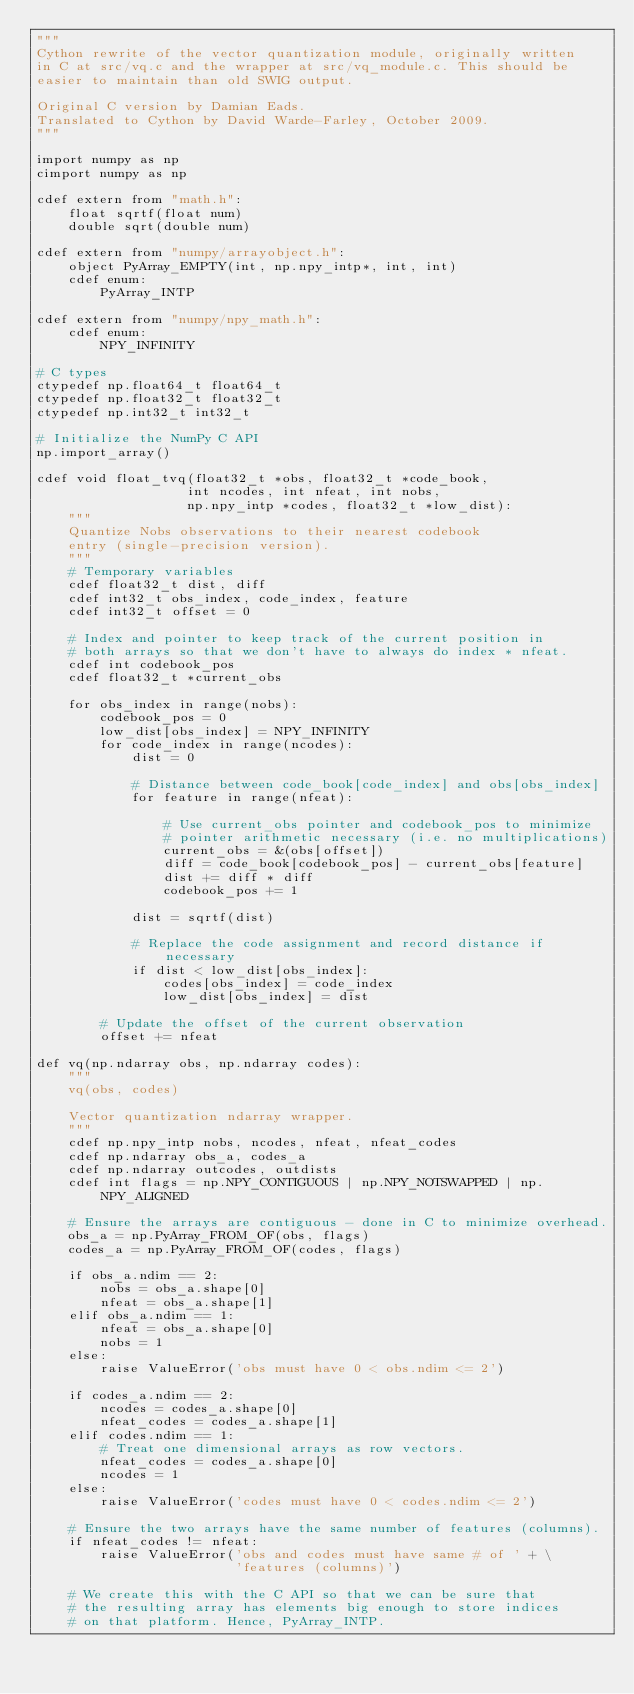<code> <loc_0><loc_0><loc_500><loc_500><_Cython_>"""
Cython rewrite of the vector quantization module, originally written
in C at src/vq.c and the wrapper at src/vq_module.c. This should be
easier to maintain than old SWIG output.

Original C version by Damian Eads. 
Translated to Cython by David Warde-Farley, October 2009.
"""

import numpy as np
cimport numpy as np

cdef extern from "math.h":
    float sqrtf(float num)
    double sqrt(double num)

cdef extern from "numpy/arrayobject.h":
    object PyArray_EMPTY(int, np.npy_intp*, int, int)
    cdef enum:
        PyArray_INTP

cdef extern from "numpy/npy_math.h":
    cdef enum:
        NPY_INFINITY

# C types
ctypedef np.float64_t float64_t
ctypedef np.float32_t float32_t
ctypedef np.int32_t int32_t

# Initialize the NumPy C API
np.import_array()

cdef void float_tvq(float32_t *obs, float32_t *code_book,
                   int ncodes, int nfeat, int nobs,
                   np.npy_intp *codes, float32_t *low_dist):
    """
    Quantize Nobs observations to their nearest codebook 
    entry (single-precision version).
    """
    # Temporary variables
    cdef float32_t dist, diff
    cdef int32_t obs_index, code_index, feature
    cdef int32_t offset = 0
    
    # Index and pointer to keep track of the current position in 
    # both arrays so that we don't have to always do index * nfeat.
    cdef int codebook_pos
    cdef float32_t *current_obs 
    
    for obs_index in range(nobs):
        codebook_pos = 0
        low_dist[obs_index] = NPY_INFINITY
        for code_index in range(ncodes):
            dist = 0
            
            # Distance between code_book[code_index] and obs[obs_index]
            for feature in range(nfeat):
                
                # Use current_obs pointer and codebook_pos to minimize
                # pointer arithmetic necessary (i.e. no multiplications)
                current_obs = &(obs[offset])
                diff = code_book[codebook_pos] - current_obs[feature]
                dist += diff * diff
                codebook_pos += 1
            
            dist = sqrtf(dist)
            
            # Replace the code assignment and record distance if necessary
            if dist < low_dist[obs_index]:
                codes[obs_index] = code_index
                low_dist[obs_index] = dist
        
        # Update the offset of the current observation
        offset += nfeat

def vq(np.ndarray obs, np.ndarray codes):
    """
    vq(obs, codes)

    Vector quantization ndarray wrapper.
    """
    cdef np.npy_intp nobs, ncodes, nfeat, nfeat_codes
    cdef np.ndarray obs_a, codes_a
    cdef np.ndarray outcodes, outdists
    cdef int flags = np.NPY_CONTIGUOUS | np.NPY_NOTSWAPPED | np.NPY_ALIGNED

    # Ensure the arrays are contiguous - done in C to minimize overhead.
    obs_a = np.PyArray_FROM_OF(obs, flags)
    codes_a = np.PyArray_FROM_OF(codes, flags)
     
    if obs_a.ndim == 2:
        nobs = obs_a.shape[0]
        nfeat = obs_a.shape[1]
    elif obs_a.ndim == 1:
        nfeat = obs_a.shape[0]
        nobs = 1
    else:
        raise ValueError('obs must have 0 < obs.ndim <= 2')
    
    if codes_a.ndim == 2:
        ncodes = codes_a.shape[0]
        nfeat_codes = codes_a.shape[1]
    elif codes.ndim == 1:
        # Treat one dimensional arrays as row vectors.
        nfeat_codes = codes_a.shape[0]
        ncodes = 1
    else:
        raise ValueError('codes must have 0 < codes.ndim <= 2')
    
    # Ensure the two arrays have the same number of features (columns).
    if nfeat_codes != nfeat:
        raise ValueError('obs and codes must have same # of ' + \
                         'features (columns)')
    
    # We create this with the C API so that we can be sure that
    # the resulting array has elements big enough to store indices
    # on that platform. Hence, PyArray_INTP.</code> 